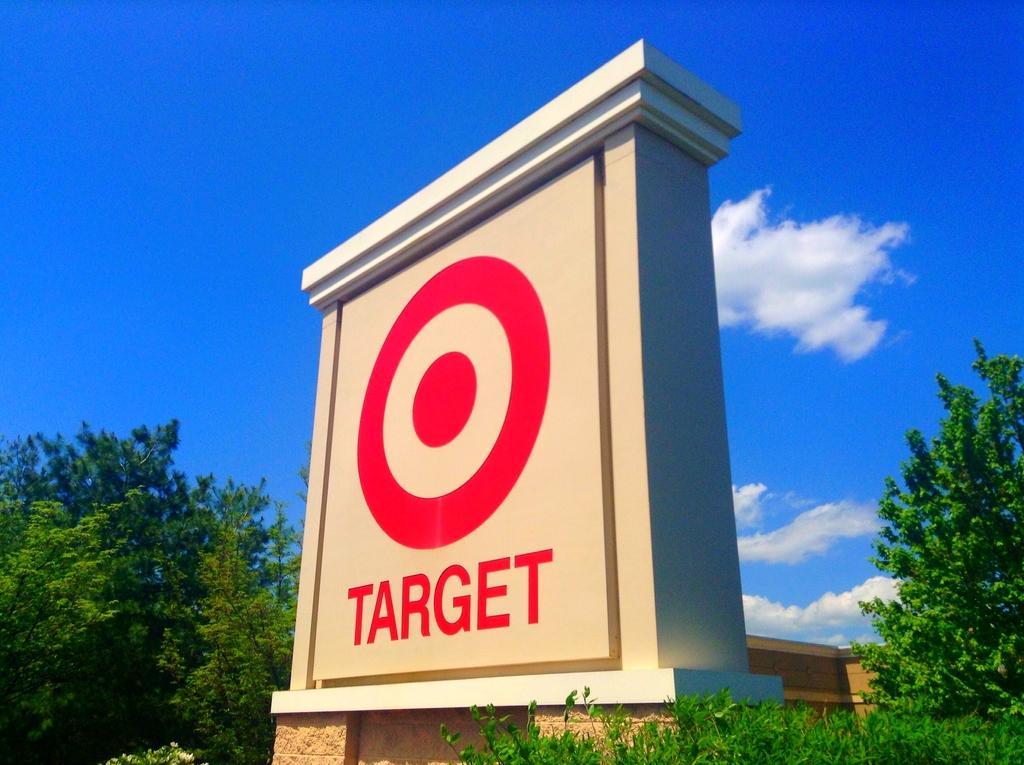How would you summarize this image in a sentence or two? In this picture there is a sign board in the center of the image and there are trees on the right and left side of the image and there is sky at the top side of the image. 